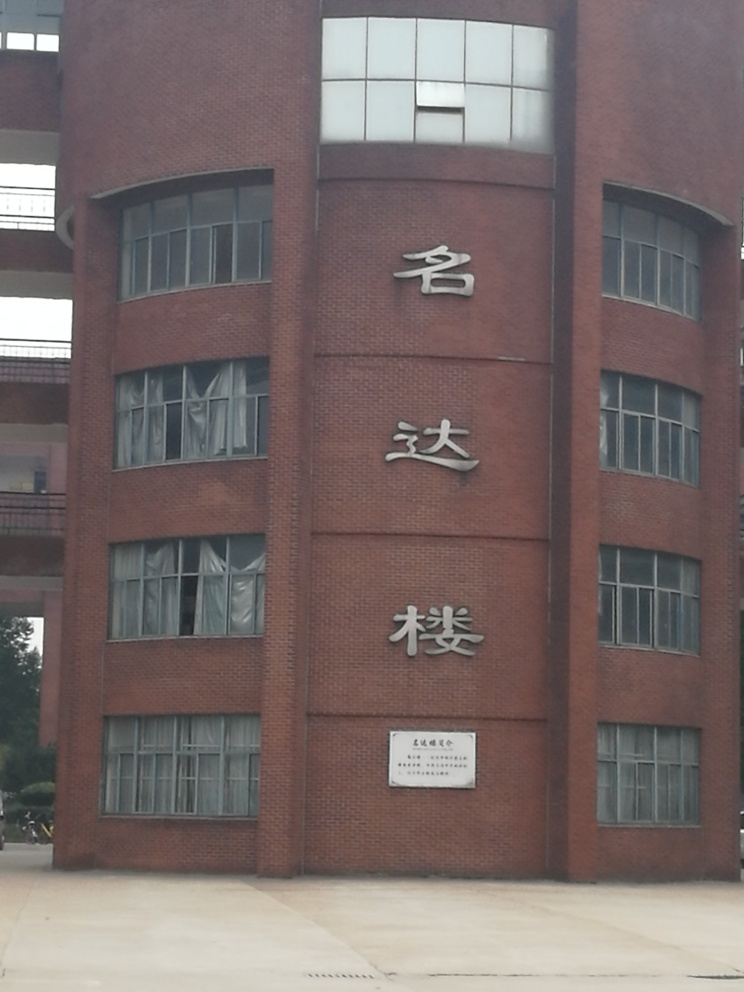What could be the potential uses of this building, based on its design and size? Based on the design and size of the building, with its large windows and prominent, centralized location as indicated by the square in front of it, it could serve educational or administrative purposes. The presence of large characters on the façade suggests it may be significant - possibly a university building, government office, or public institution. 